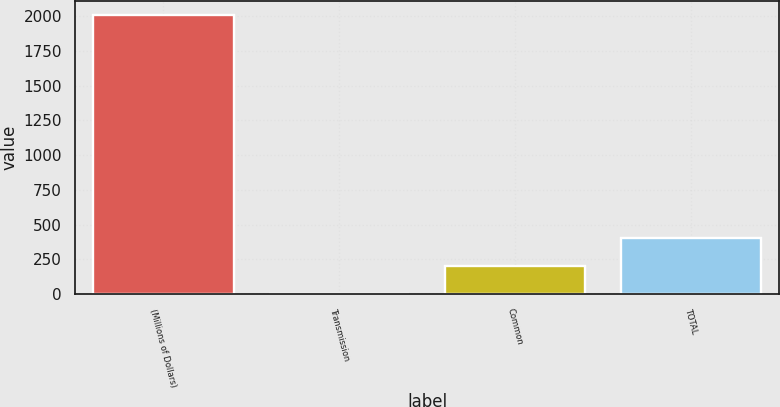<chart> <loc_0><loc_0><loc_500><loc_500><bar_chart><fcel>(Millions of Dollars)<fcel>Transmission<fcel>Common<fcel>TOTAL<nl><fcel>2008<fcel>5<fcel>205.3<fcel>405.6<nl></chart> 